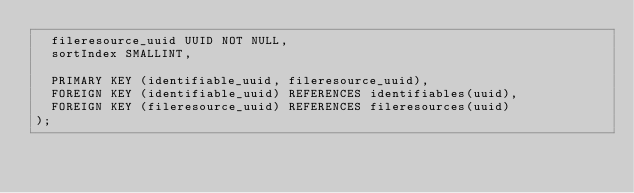Convert code to text. <code><loc_0><loc_0><loc_500><loc_500><_SQL_>  fileresource_uuid UUID NOT NULL,
  sortIndex SMALLINT,

  PRIMARY KEY (identifiable_uuid, fileresource_uuid),
  FOREIGN KEY (identifiable_uuid) REFERENCES identifiables(uuid),
  FOREIGN KEY (fileresource_uuid) REFERENCES fileresources(uuid)
);
</code> 